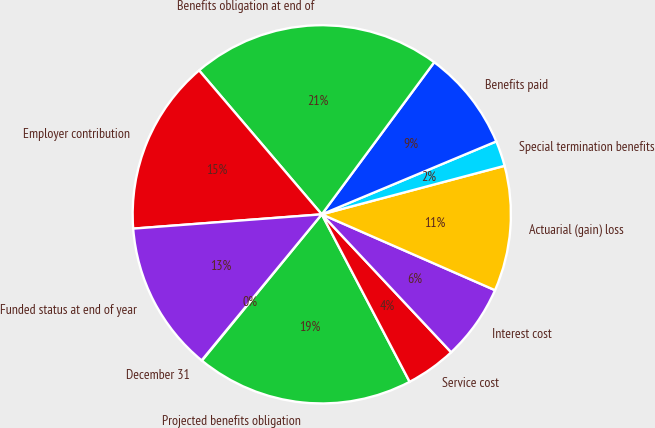Convert chart to OTSL. <chart><loc_0><loc_0><loc_500><loc_500><pie_chart><fcel>December 31<fcel>Projected benefits obligation<fcel>Service cost<fcel>Interest cost<fcel>Actuarial (gain) loss<fcel>Special termination benefits<fcel>Benefits paid<fcel>Benefits obligation at end of<fcel>Employer contribution<fcel>Funded status at end of year<nl><fcel>0.04%<fcel>18.61%<fcel>4.3%<fcel>6.44%<fcel>10.7%<fcel>2.17%<fcel>8.57%<fcel>21.37%<fcel>14.97%<fcel>12.84%<nl></chart> 